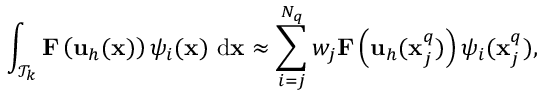<formula> <loc_0><loc_0><loc_500><loc_500>\int _ { \mathcal { T } _ { k } } F \left ( u _ { h } ( x ) \right ) { \psi } _ { i } ( x ) \ d x \approx \sum _ { i = j } ^ { N _ { q } } w _ { j } F \left ( u _ { h } ( x _ { j } ^ { q } ) \right ) { \psi } _ { i } ( x _ { j } ^ { q } ) ,</formula> 